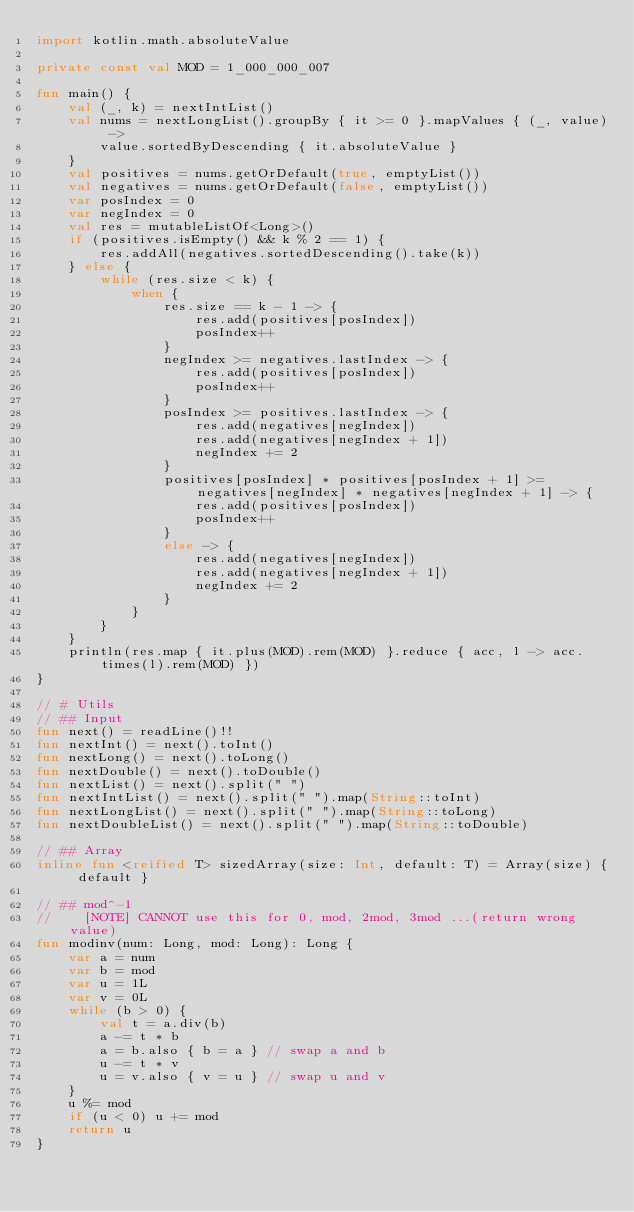Convert code to text. <code><loc_0><loc_0><loc_500><loc_500><_Kotlin_>import kotlin.math.absoluteValue

private const val MOD = 1_000_000_007

fun main() {
    val (_, k) = nextIntList()
    val nums = nextLongList().groupBy { it >= 0 }.mapValues { (_, value) ->
        value.sortedByDescending { it.absoluteValue }
    }
    val positives = nums.getOrDefault(true, emptyList())
    val negatives = nums.getOrDefault(false, emptyList())
    var posIndex = 0
    var negIndex = 0
    val res = mutableListOf<Long>()
    if (positives.isEmpty() && k % 2 == 1) {
        res.addAll(negatives.sortedDescending().take(k))
    } else {
        while (res.size < k) {
            when {
                res.size == k - 1 -> {
                    res.add(positives[posIndex])
                    posIndex++
                }
                negIndex >= negatives.lastIndex -> {
                    res.add(positives[posIndex])
                    posIndex++
                }
                posIndex >= positives.lastIndex -> {
                    res.add(negatives[negIndex])
                    res.add(negatives[negIndex + 1])
                    negIndex += 2
                }
                positives[posIndex] * positives[posIndex + 1] >= negatives[negIndex] * negatives[negIndex + 1] -> {
                    res.add(positives[posIndex])
                    posIndex++
                }
                else -> {
                    res.add(negatives[negIndex])
                    res.add(negatives[negIndex + 1])
                    negIndex += 2
                }
            }
        }
    }
    println(res.map { it.plus(MOD).rem(MOD) }.reduce { acc, l -> acc.times(l).rem(MOD) })
}

// # Utils
// ## Input
fun next() = readLine()!!
fun nextInt() = next().toInt()
fun nextLong() = next().toLong()
fun nextDouble() = next().toDouble()
fun nextList() = next().split(" ")
fun nextIntList() = next().split(" ").map(String::toInt)
fun nextLongList() = next().split(" ").map(String::toLong)
fun nextDoubleList() = next().split(" ").map(String::toDouble)

// ## Array
inline fun <reified T> sizedArray(size: Int, default: T) = Array(size) { default }

// ## mod^-1
//    [NOTE] CANNOT use this for 0, mod, 2mod, 3mod ...(return wrong value)
fun modinv(num: Long, mod: Long): Long {
    var a = num
    var b = mod
    var u = 1L
    var v = 0L
    while (b > 0) {
        val t = a.div(b)
        a -= t * b
        a = b.also { b = a } // swap a and b
        u -= t * v
        u = v.also { v = u } // swap u and v
    }
    u %= mod
    if (u < 0) u += mod
    return u
}
</code> 